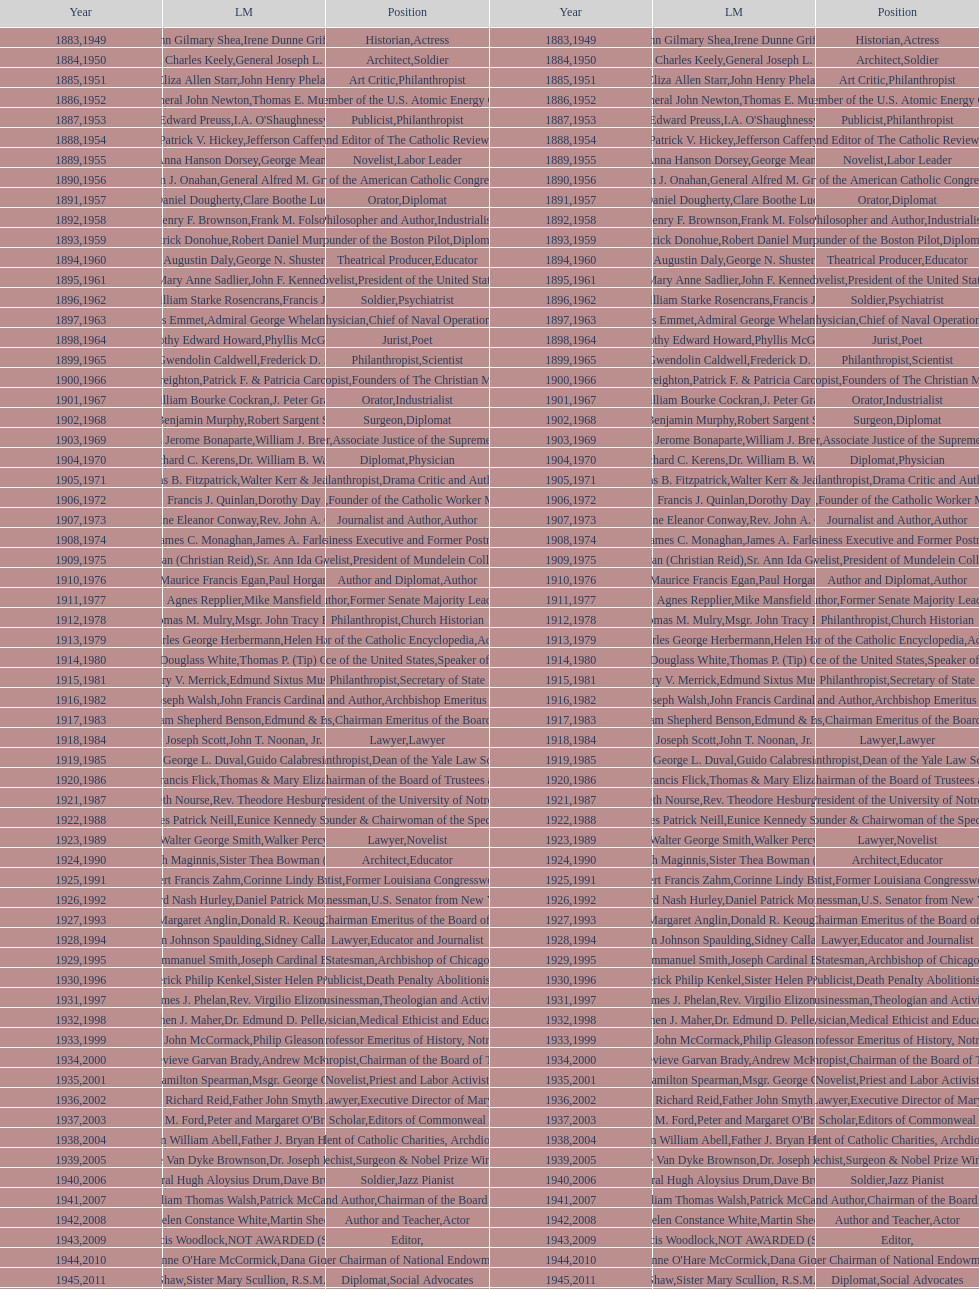Who has won this medal and the nobel prize as well? Dr. Joseph E. Murray. 